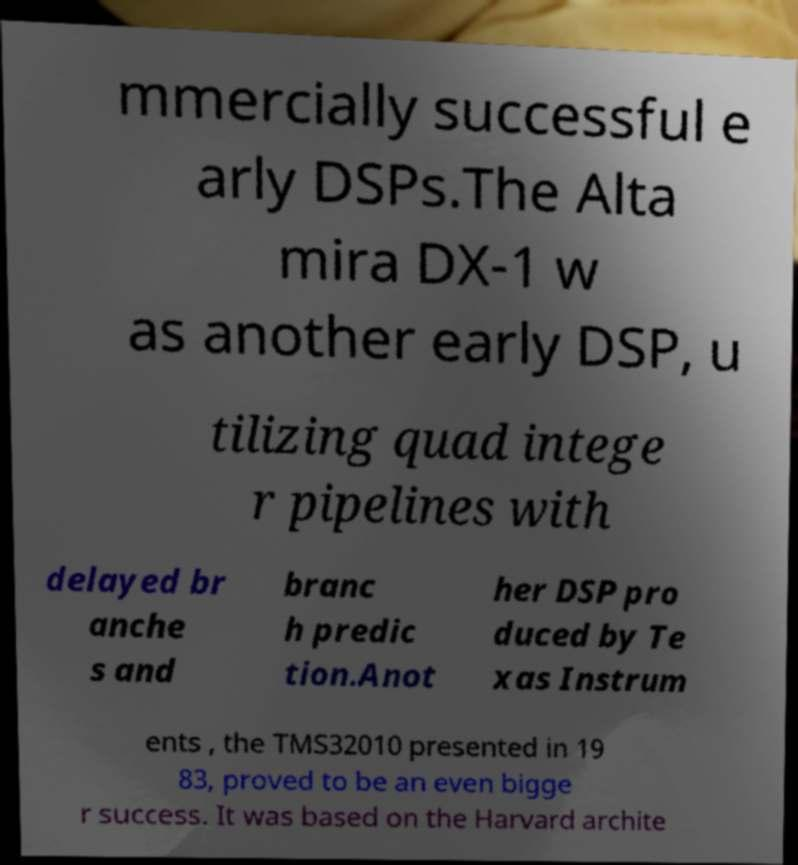Can you accurately transcribe the text from the provided image for me? mmercially successful e arly DSPs.The Alta mira DX-1 w as another early DSP, u tilizing quad intege r pipelines with delayed br anche s and branc h predic tion.Anot her DSP pro duced by Te xas Instrum ents , the TMS32010 presented in 19 83, proved to be an even bigge r success. It was based on the Harvard archite 